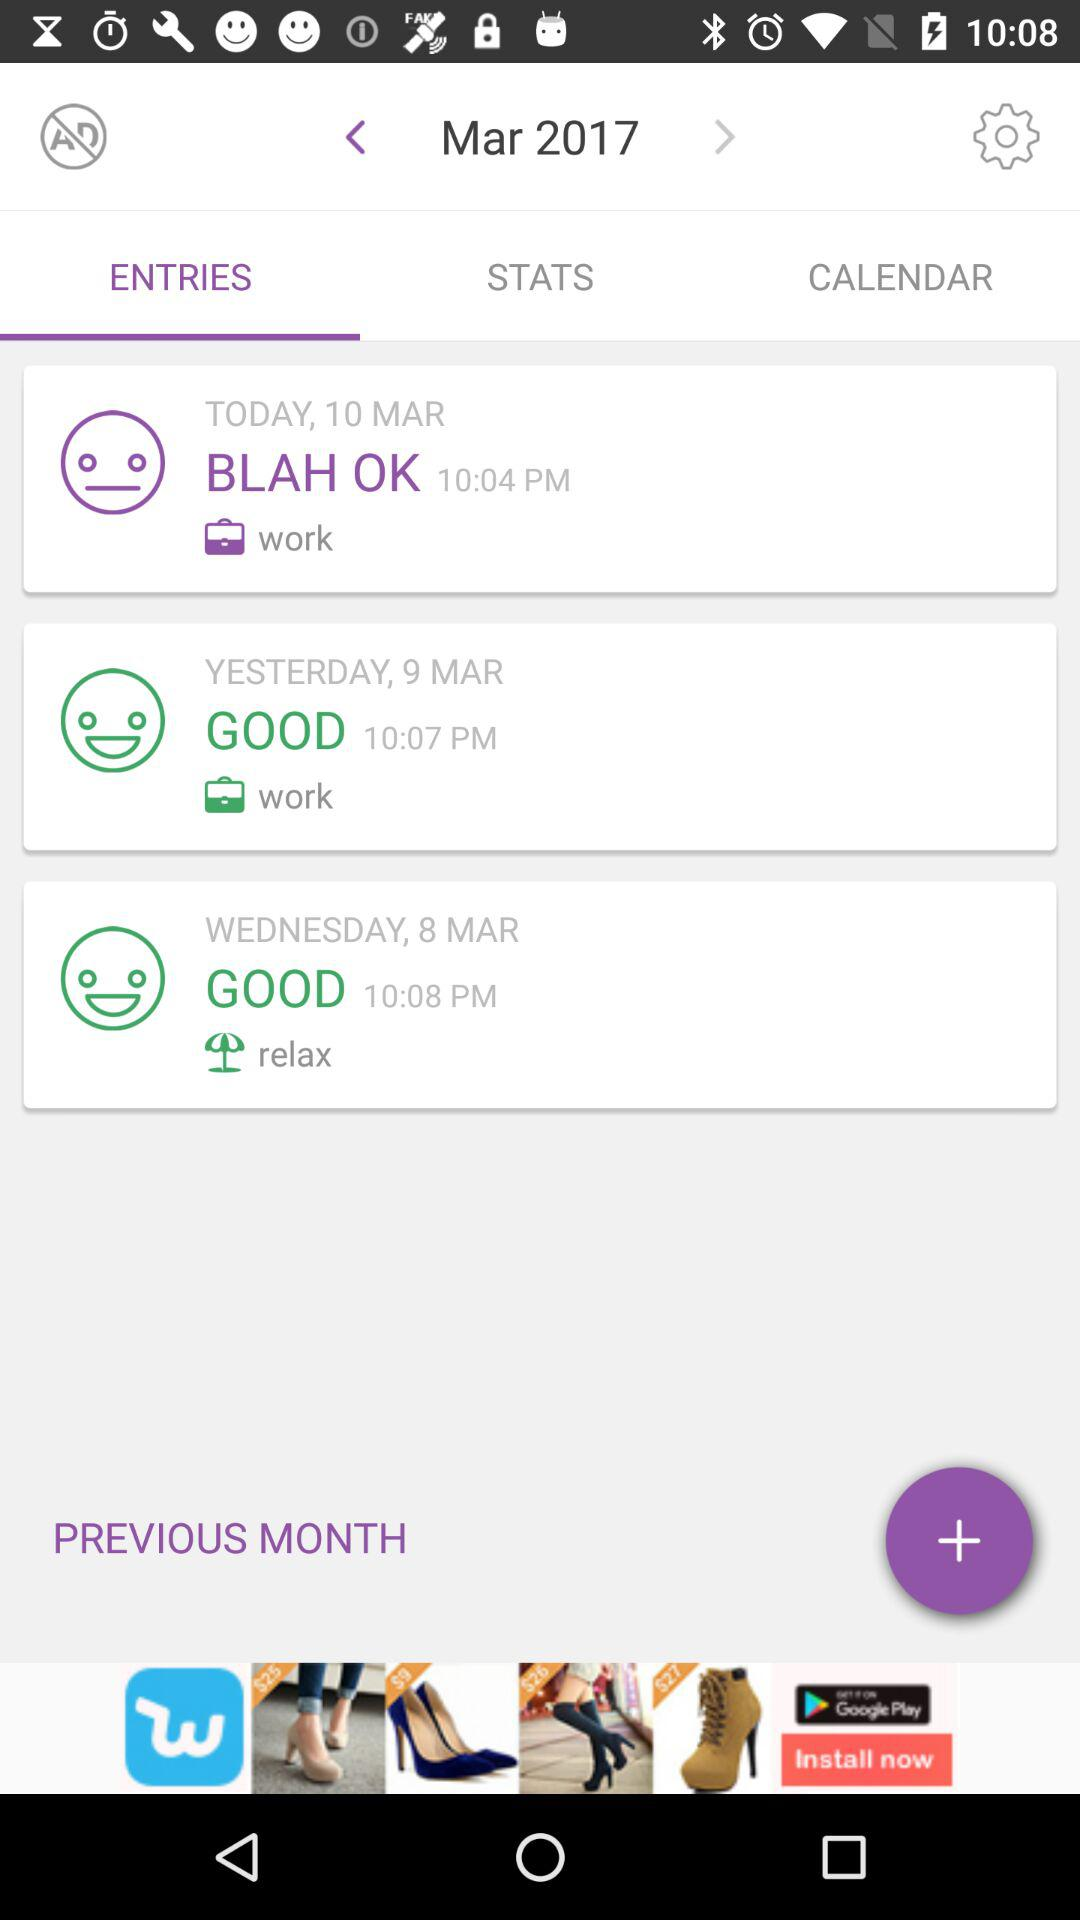At what time was the entry made on Wednesday? The entry was made on Wednesday at 10:08 PM. 